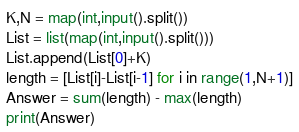<code> <loc_0><loc_0><loc_500><loc_500><_Python_>K,N = map(int,input().split())
List = list(map(int,input().split()))
List.append(List[0]+K)
length = [List[i]-List[i-1] for i in range(1,N+1)]
Answer = sum(length) - max(length)
print(Answer)</code> 